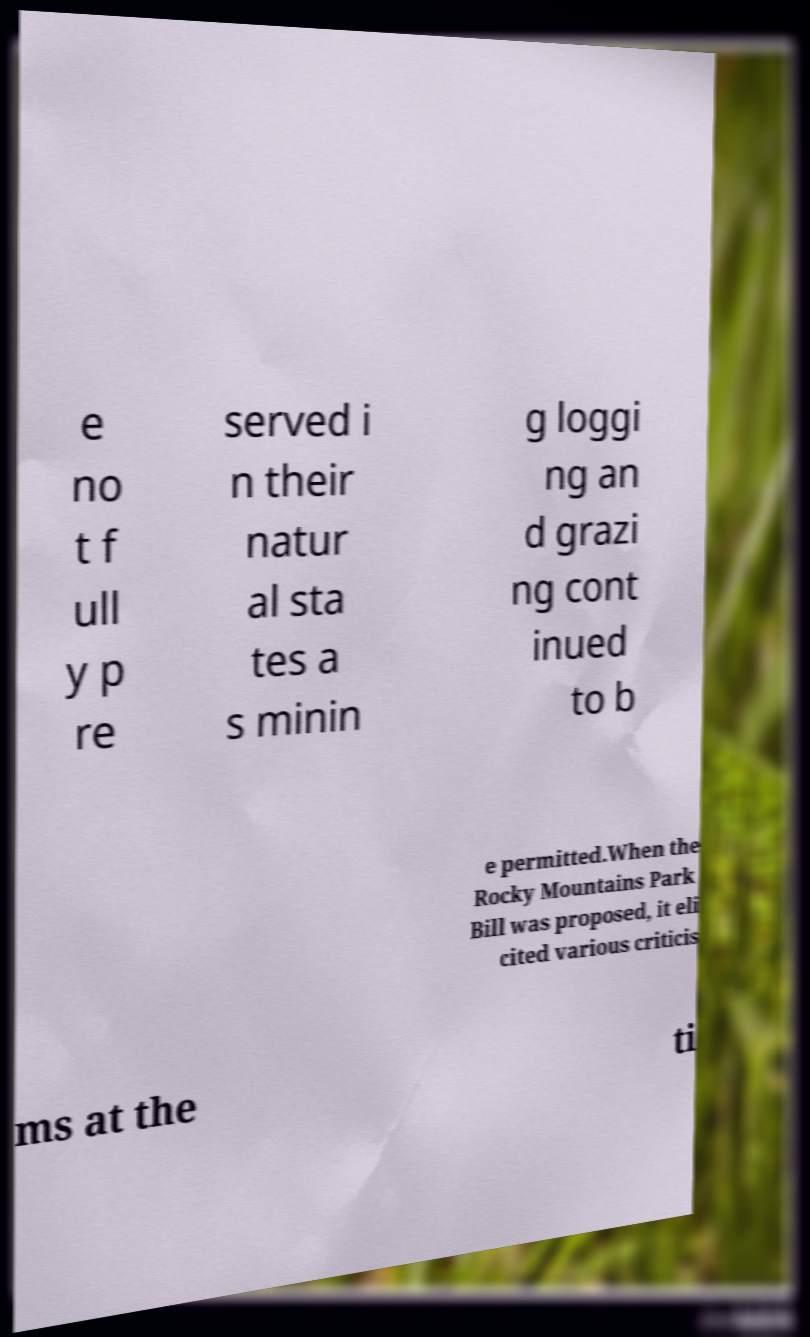Could you assist in decoding the text presented in this image and type it out clearly? e no t f ull y p re served i n their natur al sta tes a s minin g loggi ng an d grazi ng cont inued to b e permitted.When the Rocky Mountains Park Bill was proposed, it eli cited various criticis ms at the ti 